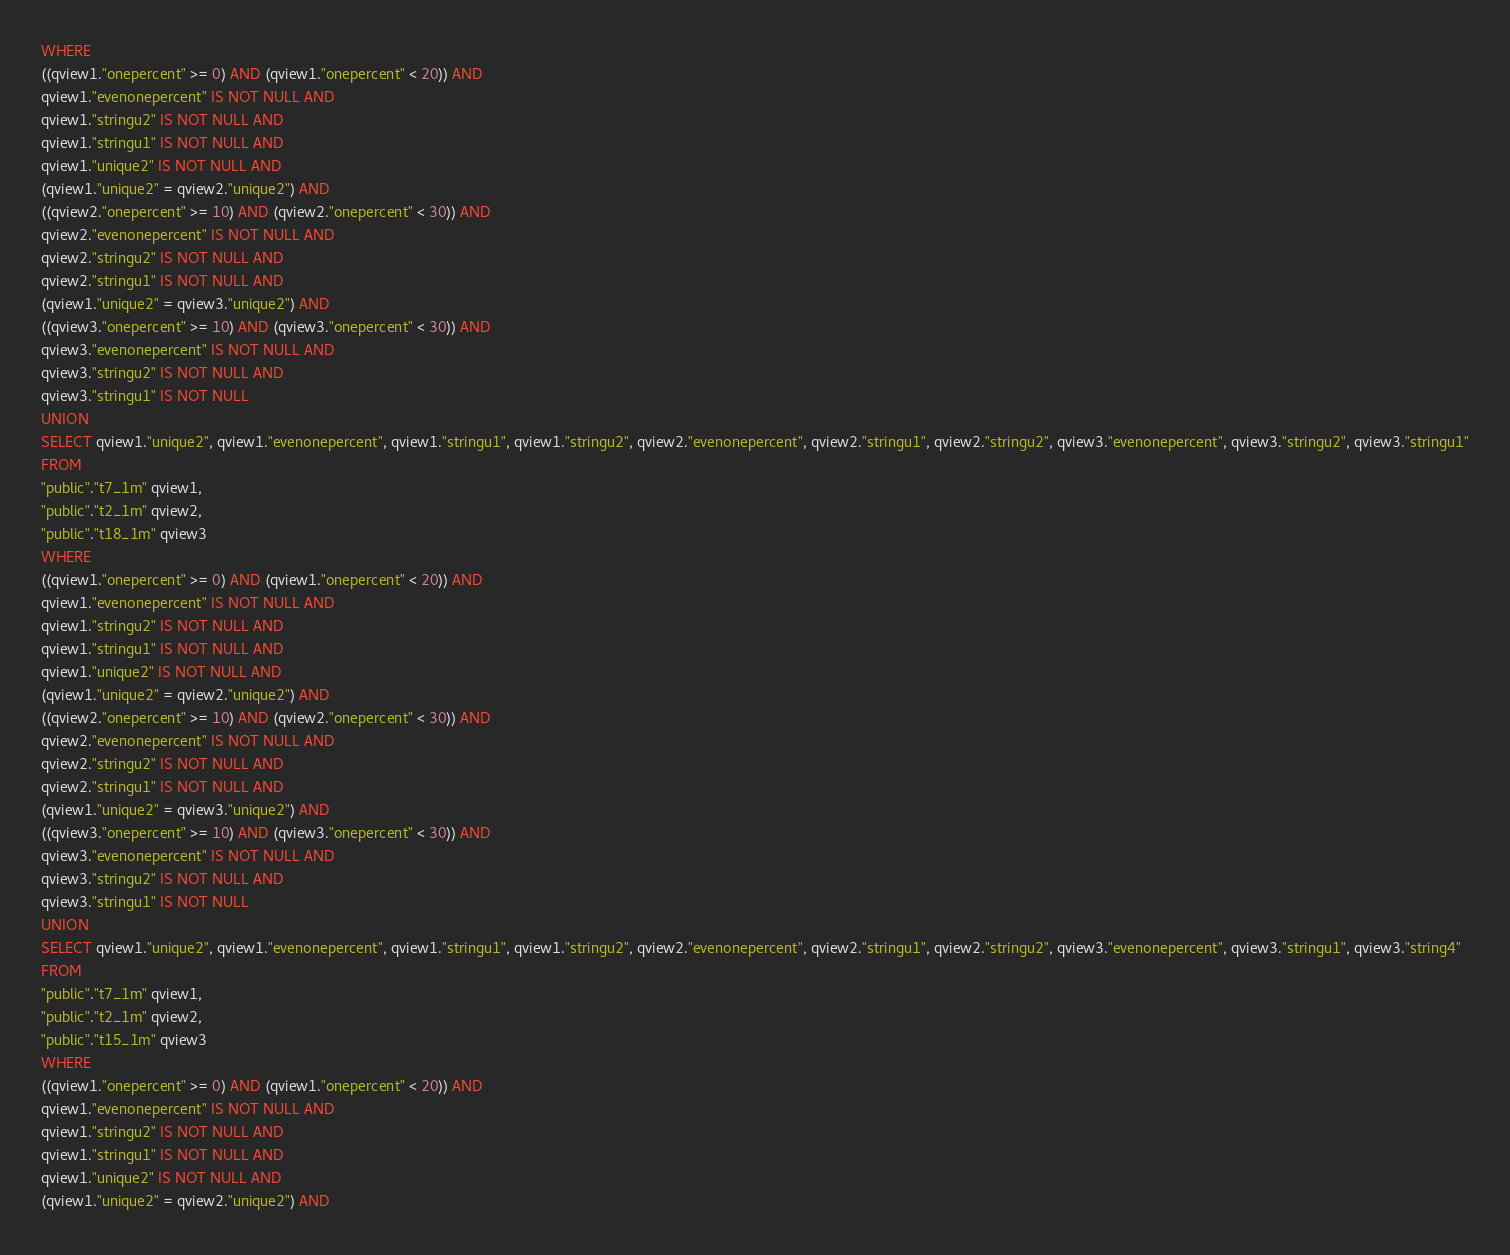Convert code to text. <code><loc_0><loc_0><loc_500><loc_500><_SQL_>WHERE
((qview1."onepercent" >= 0) AND (qview1."onepercent" < 20)) AND
qview1."evenonepercent" IS NOT NULL AND
qview1."stringu2" IS NOT NULL AND
qview1."stringu1" IS NOT NULL AND
qview1."unique2" IS NOT NULL AND
(qview1."unique2" = qview2."unique2") AND
((qview2."onepercent" >= 10) AND (qview2."onepercent" < 30)) AND
qview2."evenonepercent" IS NOT NULL AND
qview2."stringu2" IS NOT NULL AND
qview2."stringu1" IS NOT NULL AND
(qview1."unique2" = qview3."unique2") AND
((qview3."onepercent" >= 10) AND (qview3."onepercent" < 30)) AND
qview3."evenonepercent" IS NOT NULL AND
qview3."stringu2" IS NOT NULL AND
qview3."stringu1" IS NOT NULL
UNION
SELECT qview1."unique2", qview1."evenonepercent", qview1."stringu1", qview1."stringu2", qview2."evenonepercent", qview2."stringu1", qview2."stringu2", qview3."evenonepercent", qview3."stringu2", qview3."stringu1"
FROM
"public"."t7_1m" qview1,
"public"."t2_1m" qview2,
"public"."t18_1m" qview3
WHERE
((qview1."onepercent" >= 0) AND (qview1."onepercent" < 20)) AND
qview1."evenonepercent" IS NOT NULL AND
qview1."stringu2" IS NOT NULL AND
qview1."stringu1" IS NOT NULL AND
qview1."unique2" IS NOT NULL AND
(qview1."unique2" = qview2."unique2") AND
((qview2."onepercent" >= 10) AND (qview2."onepercent" < 30)) AND
qview2."evenonepercent" IS NOT NULL AND
qview2."stringu2" IS NOT NULL AND
qview2."stringu1" IS NOT NULL AND
(qview1."unique2" = qview3."unique2") AND
((qview3."onepercent" >= 10) AND (qview3."onepercent" < 30)) AND
qview3."evenonepercent" IS NOT NULL AND
qview3."stringu2" IS NOT NULL AND
qview3."stringu1" IS NOT NULL
UNION
SELECT qview1."unique2", qview1."evenonepercent", qview1."stringu1", qview1."stringu2", qview2."evenonepercent", qview2."stringu1", qview2."stringu2", qview3."evenonepercent", qview3."stringu1", qview3."string4"
FROM
"public"."t7_1m" qview1,
"public"."t2_1m" qview2,
"public"."t15_1m" qview3
WHERE
((qview1."onepercent" >= 0) AND (qview1."onepercent" < 20)) AND
qview1."evenonepercent" IS NOT NULL AND
qview1."stringu2" IS NOT NULL AND
qview1."stringu1" IS NOT NULL AND
qview1."unique2" IS NOT NULL AND
(qview1."unique2" = qview2."unique2") AND</code> 